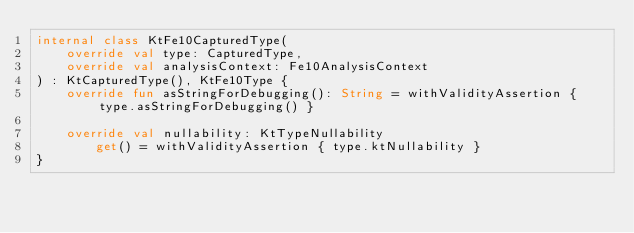<code> <loc_0><loc_0><loc_500><loc_500><_Kotlin_>internal class KtFe10CapturedType(
    override val type: CapturedType,
    override val analysisContext: Fe10AnalysisContext
) : KtCapturedType(), KtFe10Type {
    override fun asStringForDebugging(): String = withValidityAssertion { type.asStringForDebugging() }

    override val nullability: KtTypeNullability
        get() = withValidityAssertion { type.ktNullability }
}</code> 